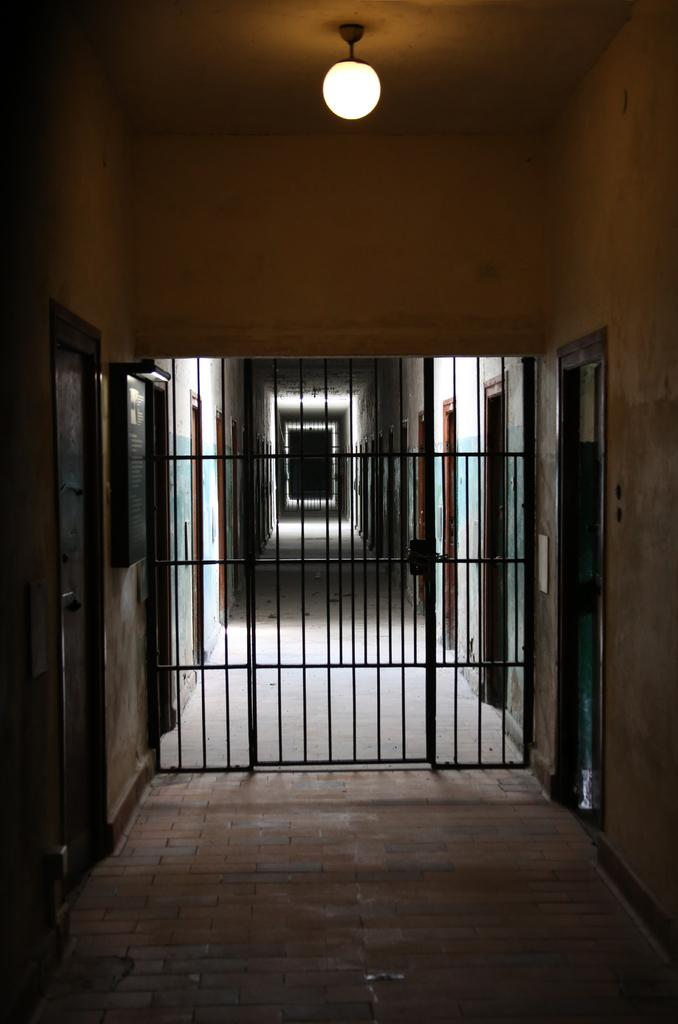What type of surface is visible in the image? There is a floor in the image. What type of entrance can be seen in the image? There is a gate in the image. Are there any openings in the image that can be used for entering or exiting? Yes, there are doors in the image. What is attached to the wall in the image? There is a frame on the wall in the image. What covers the top of the structure in the image? There is a roof in the image. Is there any source of illumination in the image? Yes, there is a light in the image. What is the name of the person standing next to the gate in the image? There is no person standing next to the gate in the image. What type of ground is visible in the image? The image does not show the ground; it only shows a floor. 